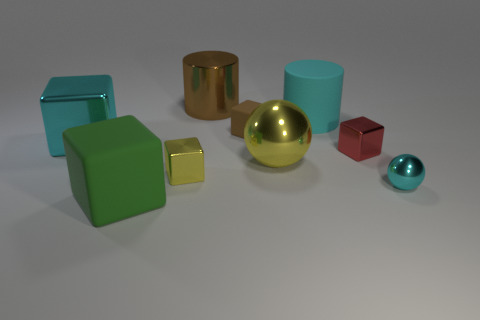Are there any things that have the same color as the large sphere?
Your answer should be very brief. Yes. There is a metallic object left of the green rubber block; is it the same size as the brown matte block?
Your answer should be very brief. No. Is the number of big yellow matte balls less than the number of brown metal cylinders?
Provide a short and direct response. Yes. Are there any other tiny spheres made of the same material as the small sphere?
Your answer should be compact. No. What shape is the big cyan thing left of the green matte cube?
Keep it short and to the point. Cube. Is the color of the object that is in front of the tiny cyan ball the same as the rubber cylinder?
Give a very brief answer. No. Is the number of tiny red metallic cubes that are to the left of the red block less than the number of large green cylinders?
Provide a succinct answer. No. The big thing that is made of the same material as the large cyan cylinder is what color?
Offer a terse response. Green. What size is the yellow cube that is in front of the large yellow metal sphere?
Ensure brevity in your answer.  Small. Are the big cyan cylinder and the tiny red object made of the same material?
Keep it short and to the point. No. 